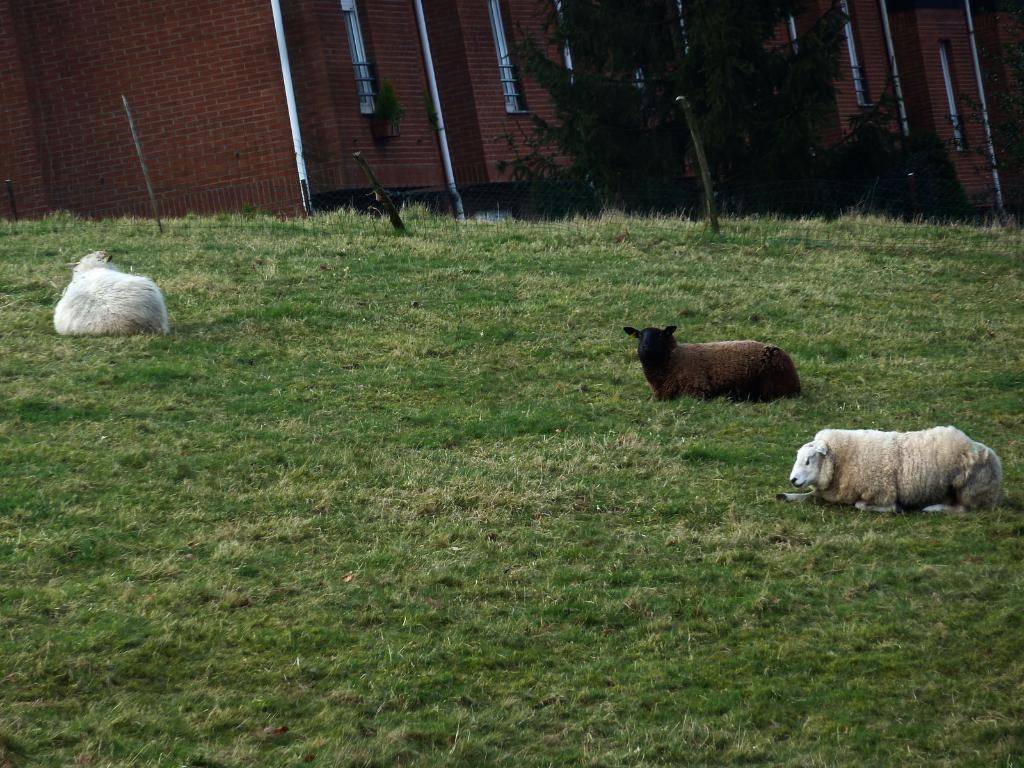What animals are in the foreground of the image? There are sheep in the foreground of the image. What is the sheep standing on? The sheep are on the grass. What can be seen at the top of the image? There is a wall visible at the top of the image. What type of vegetation is present in the image? There are trees in the image. What type of rifle is the queen holding in the image? There is no queen or rifle present in the image; it features sheep on grass with a wall and trees in the background. 